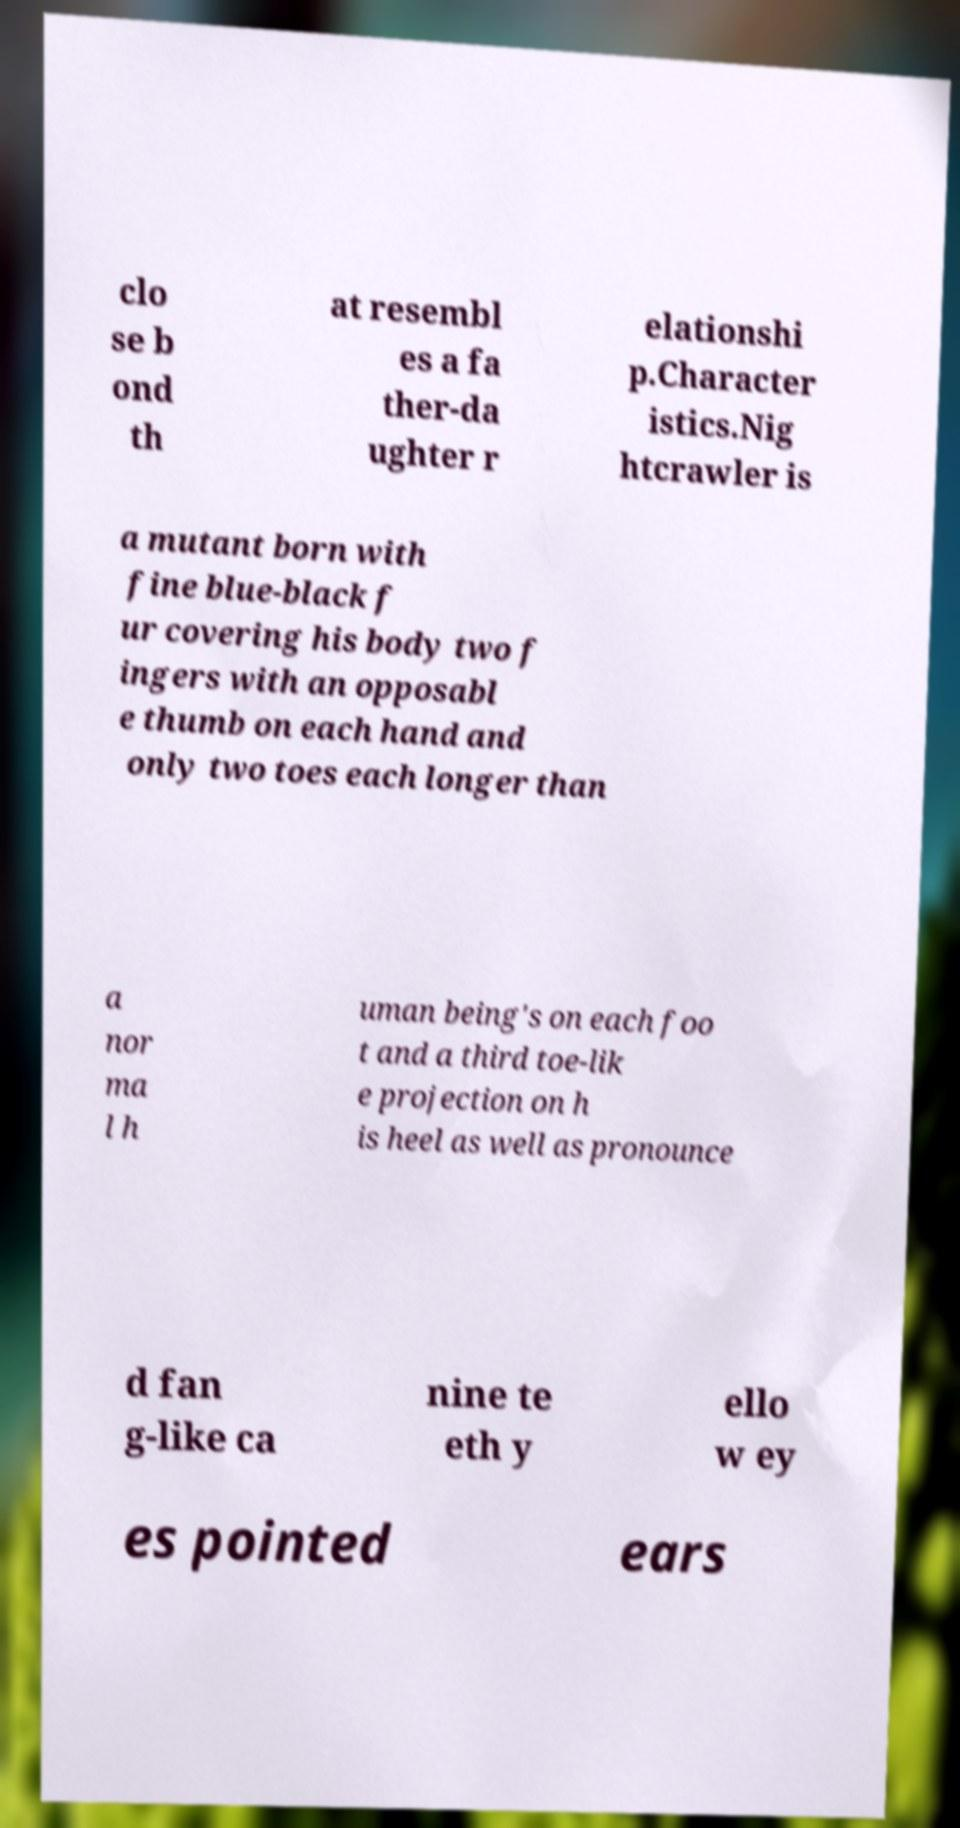Please identify and transcribe the text found in this image. clo se b ond th at resembl es a fa ther-da ughter r elationshi p.Character istics.Nig htcrawler is a mutant born with fine blue-black f ur covering his body two f ingers with an opposabl e thumb on each hand and only two toes each longer than a nor ma l h uman being's on each foo t and a third toe-lik e projection on h is heel as well as pronounce d fan g-like ca nine te eth y ello w ey es pointed ears 